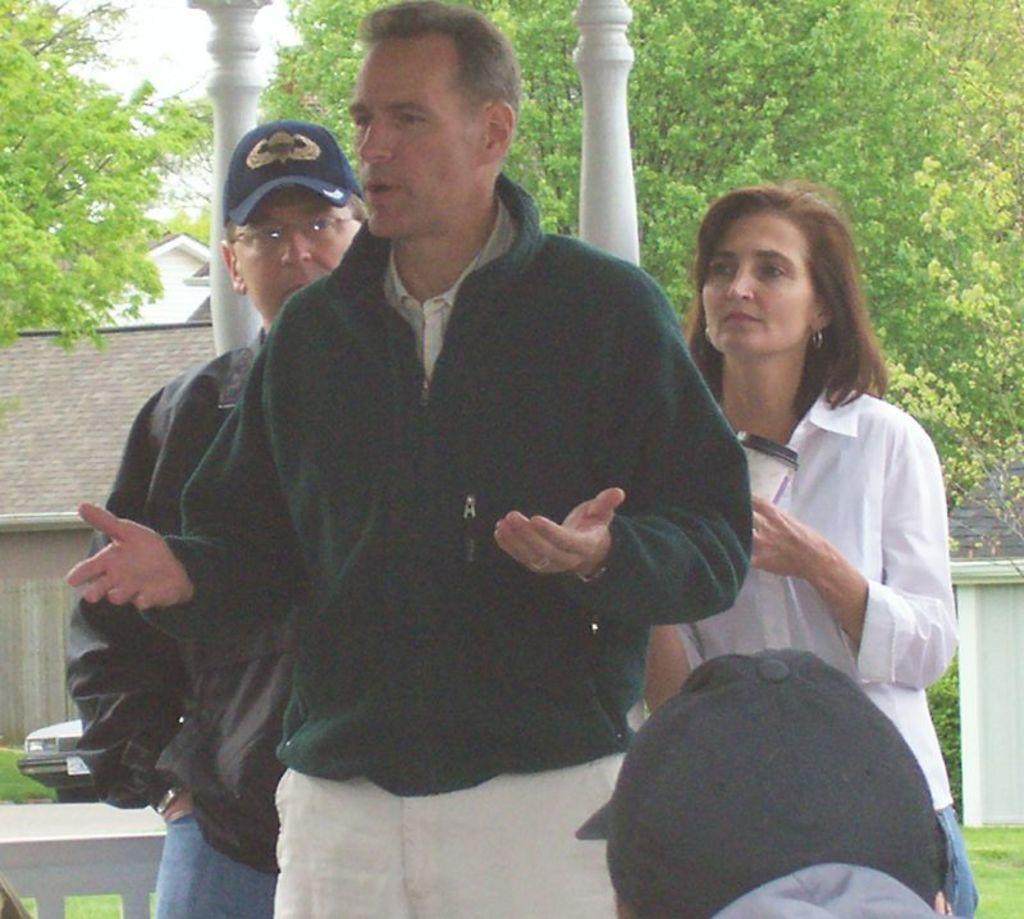Can you describe this image briefly? In this image I can see two men and a woman are standing among them this man is wearing a cap and this woman is holding an object in the hand. In the background I can see trees, pillars and houses. Here I can see a vehicle and the grass. 